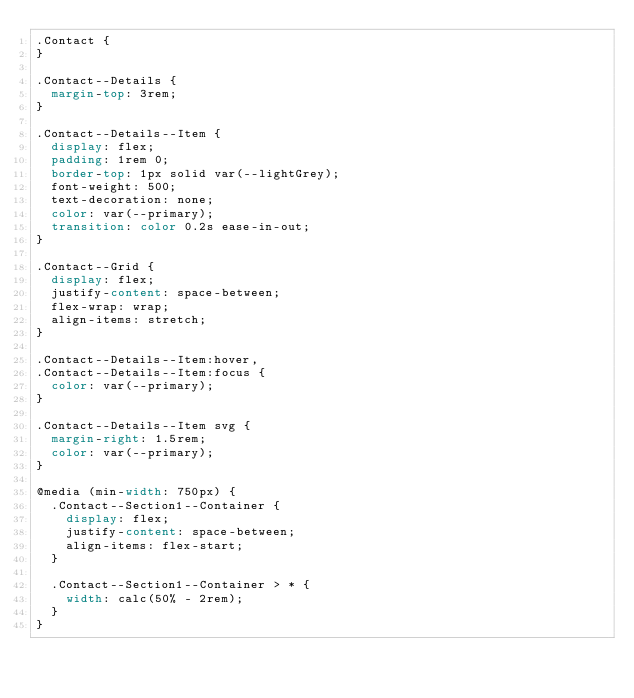<code> <loc_0><loc_0><loc_500><loc_500><_CSS_>.Contact {
}

.Contact--Details {
  margin-top: 3rem;
}

.Contact--Details--Item {
  display: flex;
  padding: 1rem 0;
  border-top: 1px solid var(--lightGrey);
  font-weight: 500;
  text-decoration: none;
  color: var(--primary);
  transition: color 0.2s ease-in-out;
}

.Contact--Grid {
  display: flex;
  justify-content: space-between;
  flex-wrap: wrap;
  align-items: stretch;
}

.Contact--Details--Item:hover,
.Contact--Details--Item:focus {
  color: var(--primary);
}

.Contact--Details--Item svg {
  margin-right: 1.5rem;
  color: var(--primary);
}

@media (min-width: 750px) {
  .Contact--Section1--Container {
    display: flex;
    justify-content: space-between;
    align-items: flex-start;
  }

  .Contact--Section1--Container > * {
    width: calc(50% - 2rem);
  }
}
</code> 